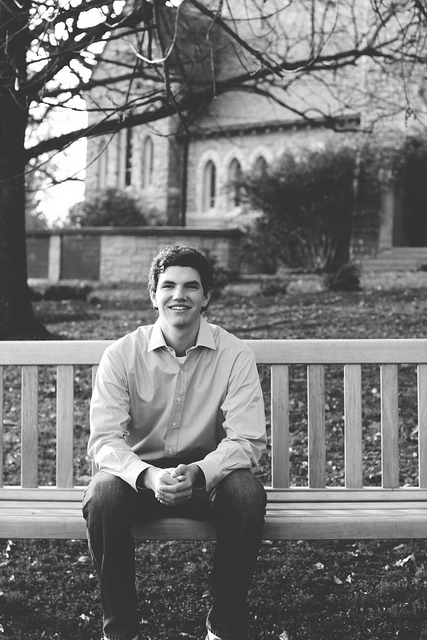<image>What city skyline is that? I don't know what city skyline is that. It could be any city such as New York, Chicago, Washington, or Boston. What city skyline is that? I don't know which city skyline it is. It can be any of ['minneapolis', 'new york city', 'chicago', 'washington', 'salem', 'boston'] or maybe there is no skyline in the image. 